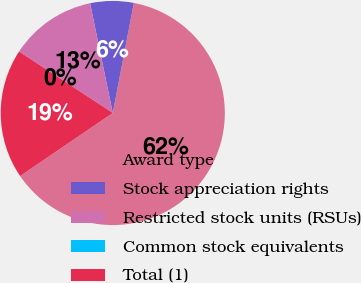<chart> <loc_0><loc_0><loc_500><loc_500><pie_chart><fcel>Award type<fcel>Stock appreciation rights<fcel>Restricted stock units (RSUs)<fcel>Common stock equivalents<fcel>Total (1)<nl><fcel>62.47%<fcel>6.26%<fcel>12.5%<fcel>0.01%<fcel>18.75%<nl></chart> 